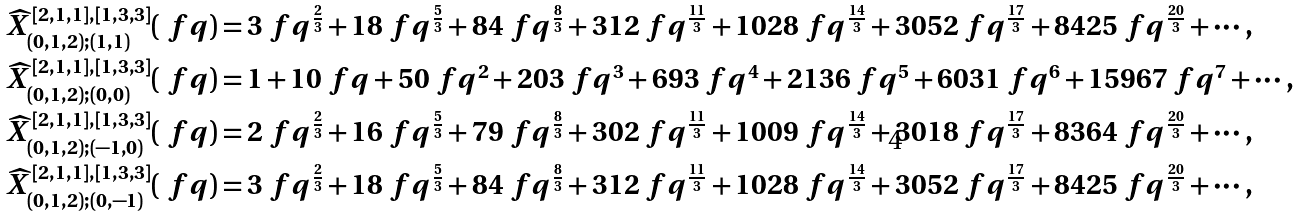Convert formula to latex. <formula><loc_0><loc_0><loc_500><loc_500>\widehat { X } _ { ( 0 , 1 , 2 ) ; ( 1 , 1 ) } ^ { \, [ 2 , 1 , 1 ] , [ 1 , 3 , 3 ] } ( \ f q ) & = 3 \ f q ^ { \frac { 2 } { 3 } } + 1 8 \ f q ^ { \frac { 5 } { 3 } } + 8 4 \ f q ^ { \frac { 8 } { 3 } } + 3 1 2 \ f q ^ { \frac { 1 1 } { 3 } } + 1 0 2 8 \ f q ^ { \frac { 1 4 } { 3 } } + 3 0 5 2 \ f q ^ { \frac { 1 7 } { 3 } } + 8 4 2 5 \ f q ^ { \frac { 2 0 } { 3 } } + \cdots \, , \\ \widehat { X } _ { ( 0 , 1 , 2 ) ; ( 0 , 0 ) } ^ { \, [ 2 , 1 , 1 ] , [ 1 , 3 , 3 ] } ( \ f q ) & = 1 + 1 0 \ f q + 5 0 \ f q ^ { 2 } + 2 0 3 \ f q ^ { 3 } + 6 9 3 \ f q ^ { 4 } + 2 1 3 6 \ f q ^ { 5 } + 6 0 3 1 \ f q ^ { 6 } + 1 5 9 6 7 \ f q ^ { 7 } + \cdots \, , \\ \widehat { X } _ { ( 0 , 1 , 2 ) ; ( - 1 , 0 ) } ^ { \, [ 2 , 1 , 1 ] , [ 1 , 3 , 3 ] } ( \ f q ) & = 2 \ f q ^ { \frac { 2 } { 3 } } + 1 6 \ f q ^ { \frac { 5 } { 3 } } + 7 9 \ f q ^ { \frac { 8 } { 3 } } + 3 0 2 \ f q ^ { \frac { 1 1 } { 3 } } + 1 0 0 9 \ f q ^ { \frac { 1 4 } { 3 } } + 3 0 1 8 \ f q ^ { \frac { 1 7 } { 3 } } + 8 3 6 4 \ f q ^ { \frac { 2 0 } { 3 } } + \cdots \, , \\ \widehat { X } _ { ( 0 , 1 , 2 ) ; ( 0 , - 1 ) } ^ { \, [ 2 , 1 , 1 ] , [ 1 , 3 , 3 ] } ( \ f q ) & = 3 \ f q ^ { \frac { 2 } { 3 } } + 1 8 \ f q ^ { \frac { 5 } { 3 } } + 8 4 \ f q ^ { \frac { 8 } { 3 } } + 3 1 2 \ f q ^ { \frac { 1 1 } { 3 } } + 1 0 2 8 \ f q ^ { \frac { 1 4 } { 3 } } + 3 0 5 2 \ f q ^ { \frac { 1 7 } { 3 } } + 8 4 2 5 \ f q ^ { \frac { 2 0 } { 3 } } + \cdots \, ,</formula> 